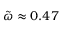Convert formula to latex. <formula><loc_0><loc_0><loc_500><loc_500>\tilde { \omega } \approx 0 . 4 7</formula> 